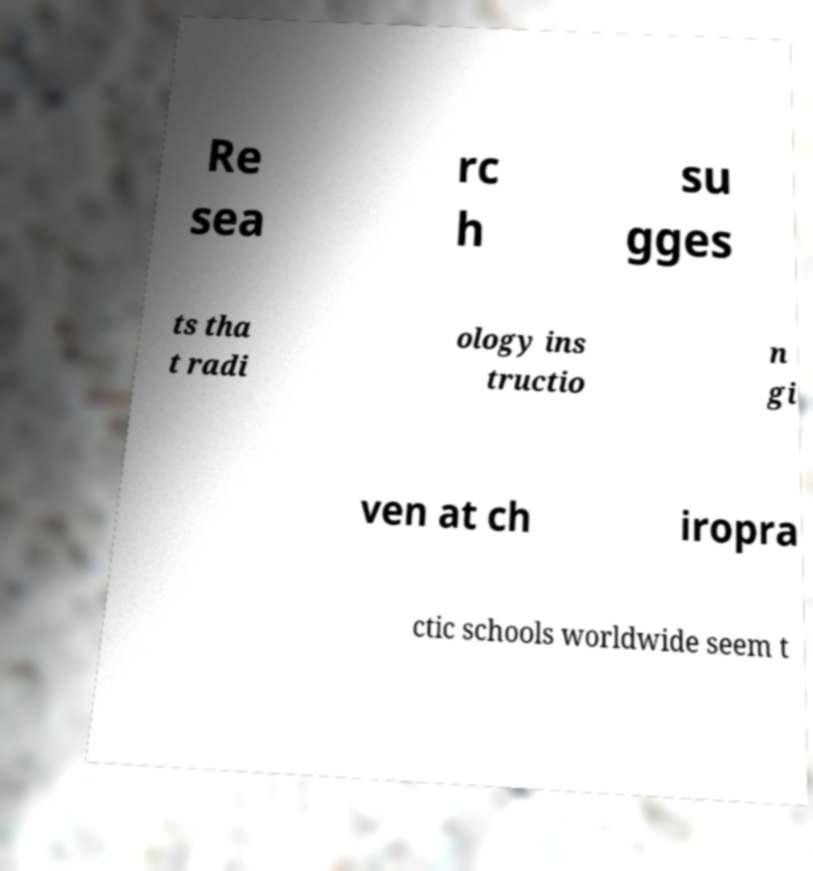Please read and relay the text visible in this image. What does it say? Re sea rc h su gges ts tha t radi ology ins tructio n gi ven at ch iropra ctic schools worldwide seem t 